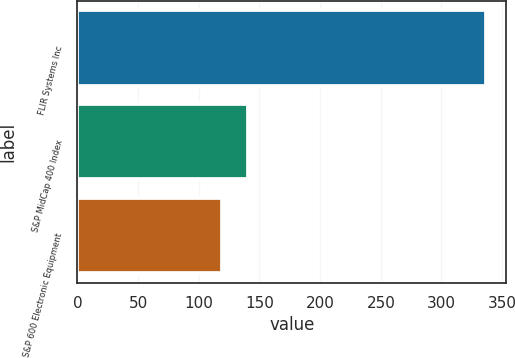Convert chart to OTSL. <chart><loc_0><loc_0><loc_500><loc_500><bar_chart><fcel>FLIR Systems Inc<fcel>S&P MidCap 400 Index<fcel>S&P 600 Electronic Equipment<nl><fcel>336.45<fcel>140.58<fcel>118.82<nl></chart> 